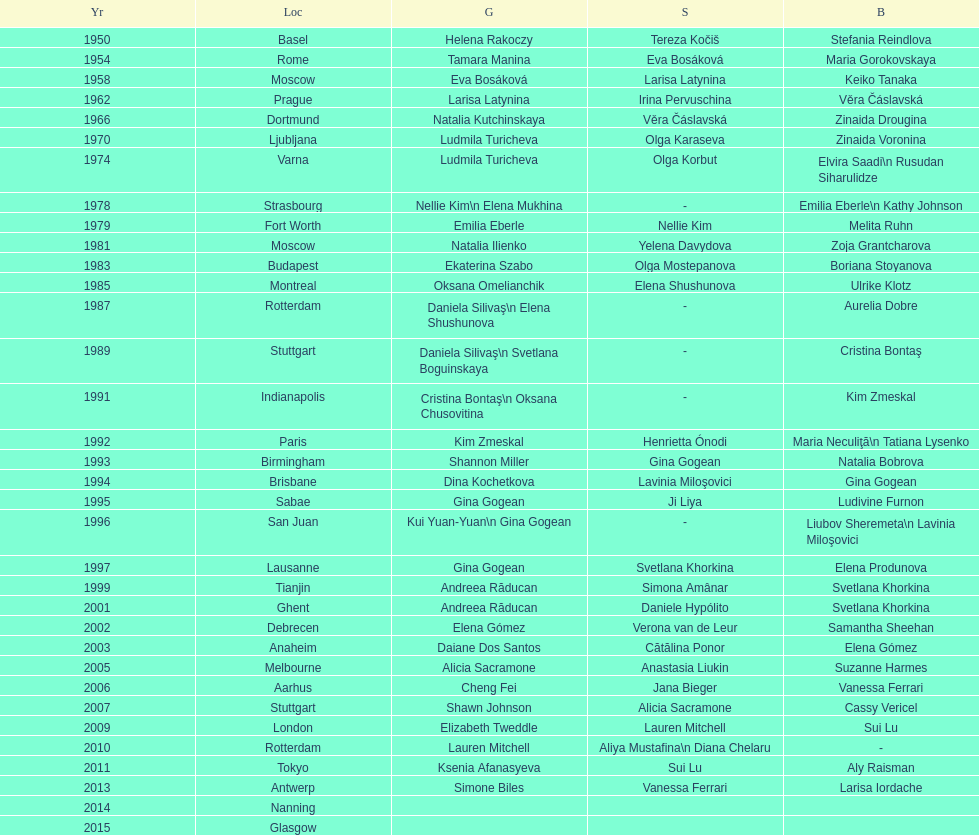Where were the championships held before the 1962 prague championships? Moscow. 